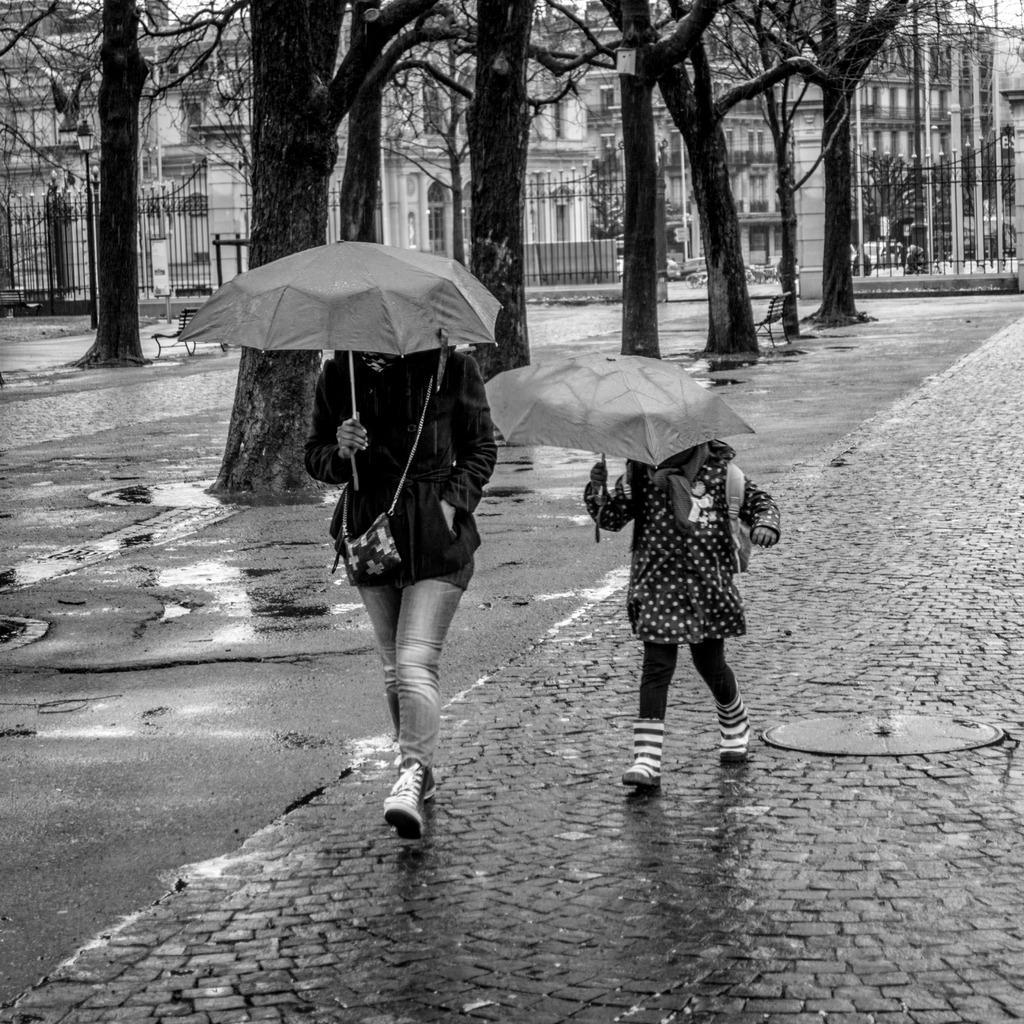Could you give a brief overview of what you see in this image? There is one woman and a kid are holding umbrellas as we can see in the middle of this image. We can see trees and buildings in the background. 